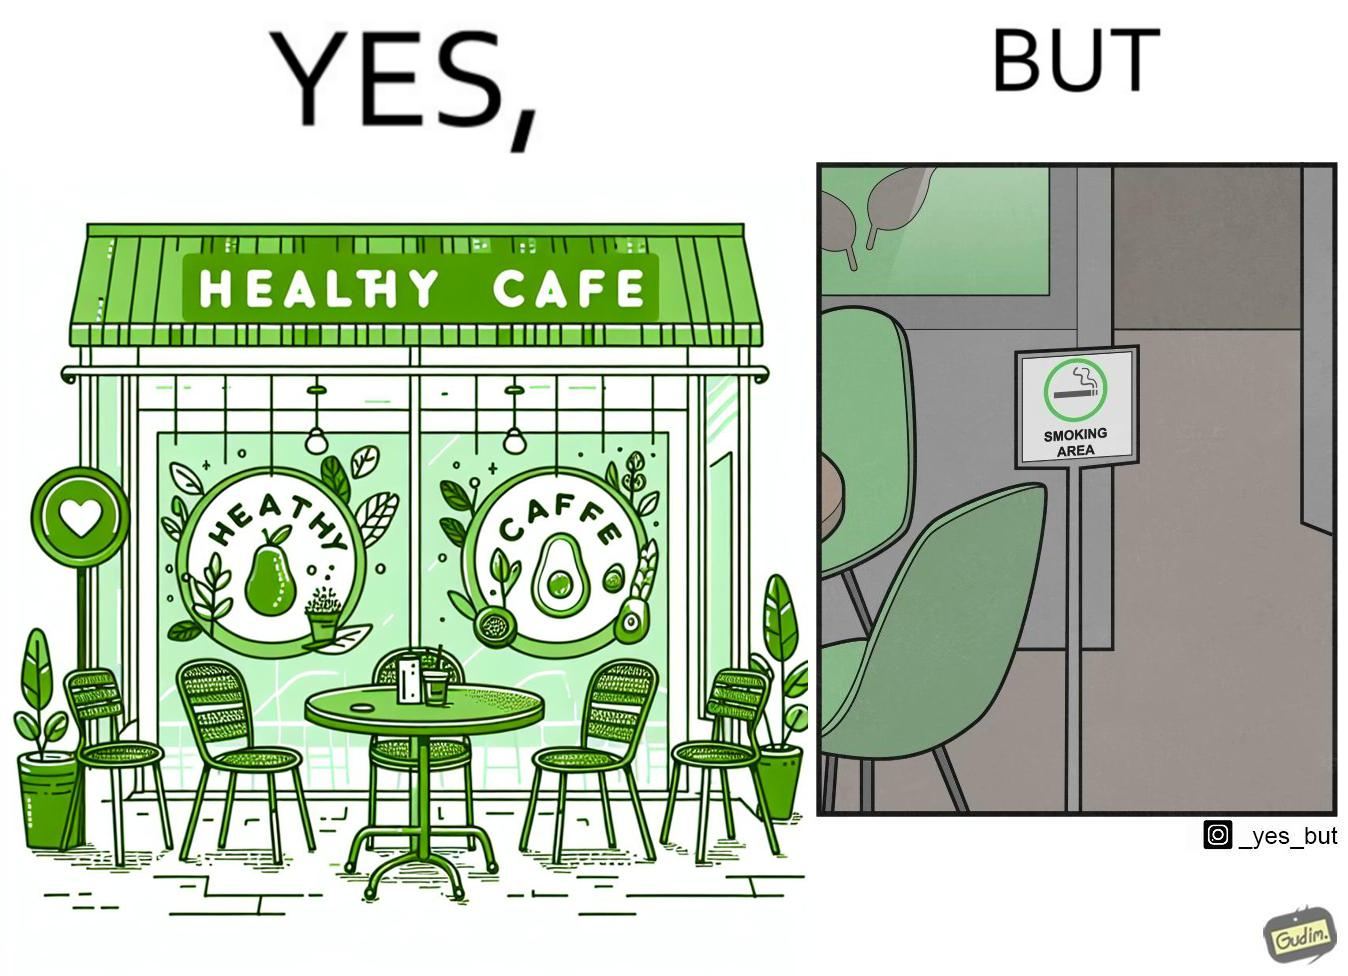Explain the humor or irony in this image. This image is funny because an eatery that calls itself the "healthy" cafe also has a smoking area, which is not very "healthy". If it really was a healthy cafe, it would not have a smoking area as smoking is injurious to health. Satire on the behavior of humans - both those that operate this cafe who made the decision of allowing smoking and creating a designated smoking area, and those that visit this healthy cafe to become "healthy", but then also indulge in very unhealthy habits simultaneously. 